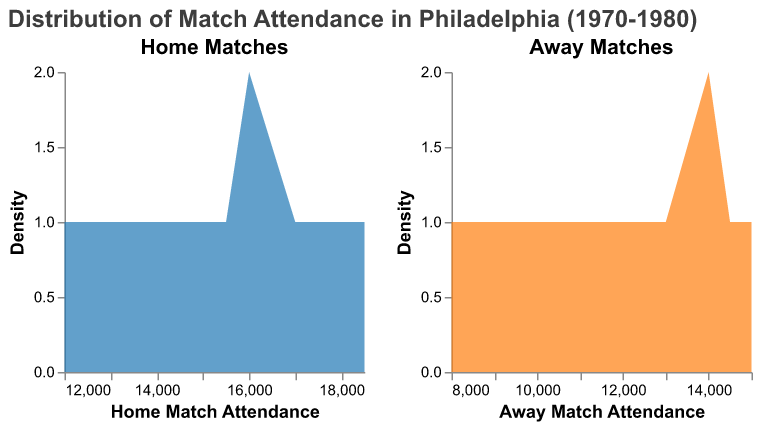What is the title of the figure? The title of the figure is typically written at the top. Here, it's shown above the density plots.
Answer: Distribution of Match Attendance in Philadelphia (1970-1980) What color represents the density plot for home matches? The density plot for home matches is shown in a specific color in the figure.
Answer: Blue How many home matches had an attendance of 17,000? Look at the x-axis of the home match density plot and identify the point where attendance is 17,000. Then, check the corresponding density value on the y-axis. There is a peak around 17000, indicating one match.
Answer: 1 What is the density of away matches with an attendance of 15000? On the x-axis of the away match density plot, find the density value corresponding to 15000. The density is given by the height at this point on the y-axis.
Answer: Approximately 1 How does the peak density of home matches compare to that of away matches? Compare the highest points (peaks) of both density plots: the blue one for home matches and the orange one for away matches. Notice the peak height.
Answer: The peak density is higher for home matches Which attendance range has the highest density for home matches? Look for the highest point in the home matches density plot and note its corresponding x-axis value. This range is the attendance area with the peak density.
Answer: 14,500 to 17,000 Are away matches generally lower in attendance compared to home matches? Evaluate the overall ranges and peaks of both density plots. The away matches (orange) tend to have lower attendance values concentrated around 14,000 compared to home matches (blue), which peak around 17,000.
Answer: Yes What is the median attendance for home matches? Since the density plot does not directly show medians, look at the area under the curve. The median is where half of the area is to its left and half to its right.
Answer: Approximately 16,000 Do home matches have a higher propensity to reach attendances above 18,000 compared to away matches? Examine the tail ends of the density plots. Home matches (blue) show higher density tails reaching around 18,000 compared to away matches (orange), which peak at around 15,000.
Answer: Yes In which year did home match attendance peak the highest? Observing the frequency and density peaks in the home matches plot, especially referring to the figure, will tell when the attendance was the highest. The highest attendance is around the 1975 home match data point.
Answer: 1980 